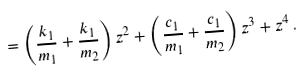Convert formula to latex. <formula><loc_0><loc_0><loc_500><loc_500>= \left ( \frac { k _ { 1 } } { m _ { 1 } } + \frac { k _ { 1 } } { m _ { 2 } } \right ) z ^ { 2 } + \left ( \frac { c _ { 1 } } { m _ { 1 } } + \frac { c _ { 1 } } { m _ { 2 } } \right ) z ^ { 3 } + z ^ { 4 } \, .</formula> 